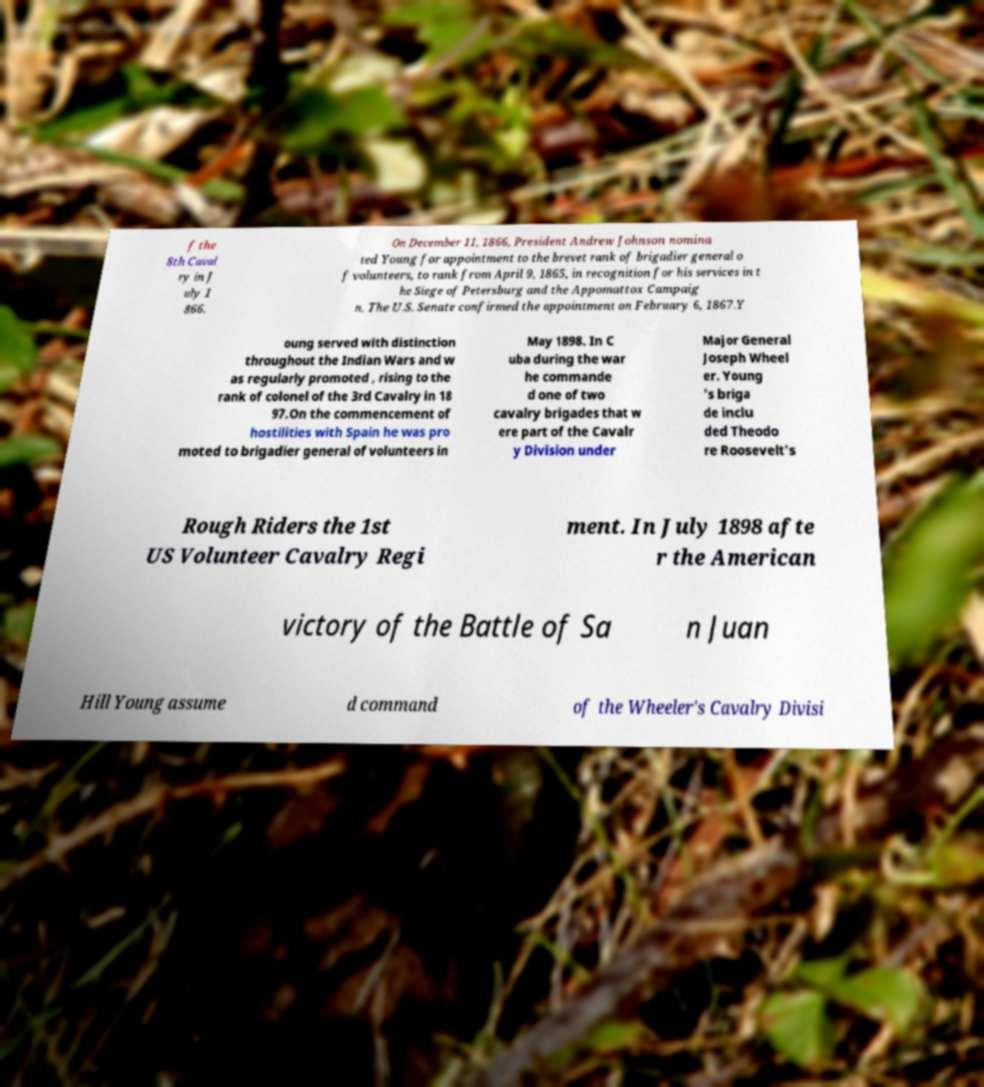Can you accurately transcribe the text from the provided image for me? f the 8th Caval ry in J uly 1 866. On December 11, 1866, President Andrew Johnson nomina ted Young for appointment to the brevet rank of brigadier general o f volunteers, to rank from April 9, 1865, in recognition for his services in t he Siege of Petersburg and the Appomattox Campaig n. The U.S. Senate confirmed the appointment on February 6, 1867.Y oung served with distinction throughout the Indian Wars and w as regularly promoted , rising to the rank of colonel of the 3rd Cavalry in 18 97.On the commencement of hostilities with Spain he was pro moted to brigadier general of volunteers in May 1898. In C uba during the war he commande d one of two cavalry brigades that w ere part of the Cavalr y Division under Major General Joseph Wheel er. Young 's briga de inclu ded Theodo re Roosevelt's Rough Riders the 1st US Volunteer Cavalry Regi ment. In July 1898 afte r the American victory of the Battle of Sa n Juan Hill Young assume d command of the Wheeler's Cavalry Divisi 